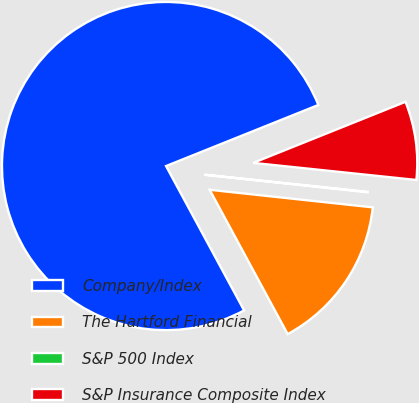Convert chart. <chart><loc_0><loc_0><loc_500><loc_500><pie_chart><fcel>Company/Index<fcel>The Hartford Financial<fcel>S&P 500 Index<fcel>S&P Insurance Composite Index<nl><fcel>76.81%<fcel>15.4%<fcel>0.05%<fcel>7.73%<nl></chart> 